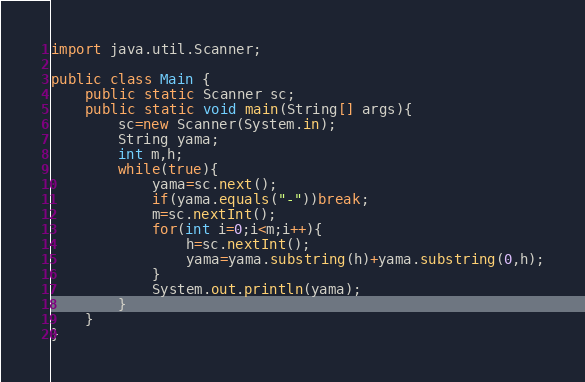Convert code to text. <code><loc_0><loc_0><loc_500><loc_500><_Java_>import java.util.Scanner;

public class Main {
	public static Scanner sc;
	public static void main(String[] args){
		sc=new Scanner(System.in);
		String yama;
		int m,h;
		while(true){
			yama=sc.next();
			if(yama.equals("-"))break;
			m=sc.nextInt();
			for(int i=0;i<m;i++){
				h=sc.nextInt();
				yama=yama.substring(h)+yama.substring(0,h);
			}
			System.out.println(yama);
		}
	}
}</code> 